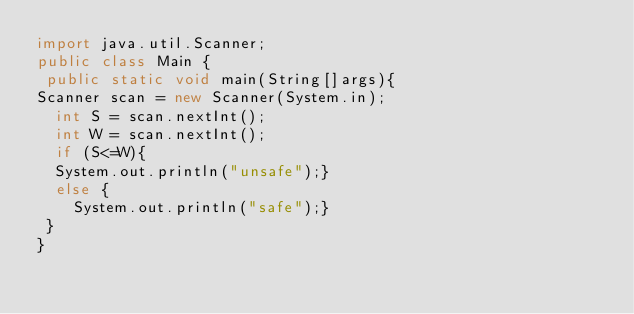Convert code to text. <code><loc_0><loc_0><loc_500><loc_500><_Java_>import java.util.Scanner;
public class Main {
 public static void main(String[]args){
Scanner scan = new Scanner(System.in);
  int S = scan.nextInt();
  int W = scan.nextInt();
  if (S<=W){
  System.out.println("unsafe");}
  else {
    System.out.println("safe");}
 }
}</code> 